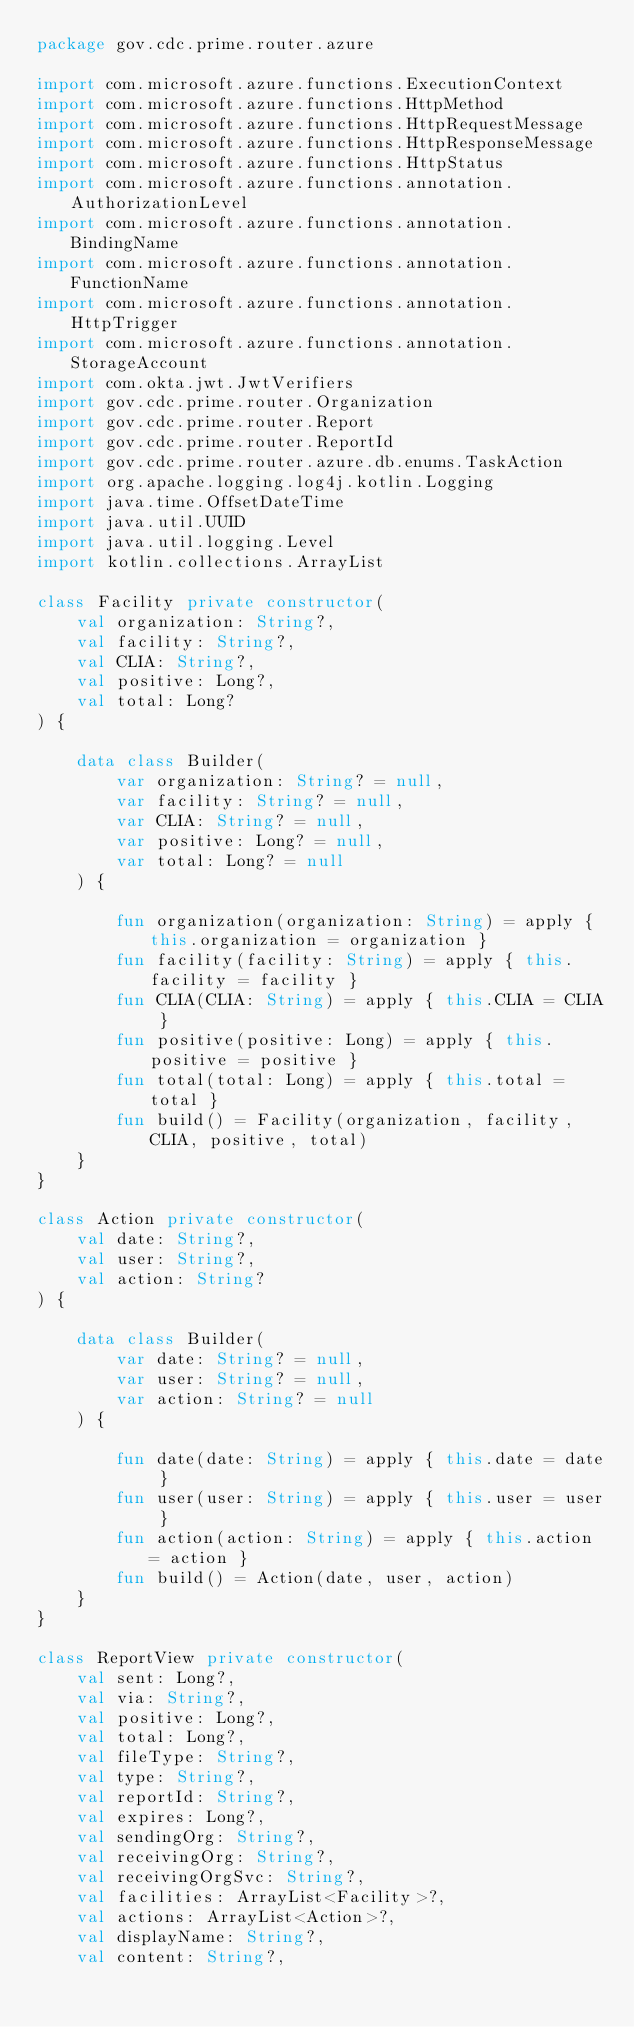Convert code to text. <code><loc_0><loc_0><loc_500><loc_500><_Kotlin_>package gov.cdc.prime.router.azure

import com.microsoft.azure.functions.ExecutionContext
import com.microsoft.azure.functions.HttpMethod
import com.microsoft.azure.functions.HttpRequestMessage
import com.microsoft.azure.functions.HttpResponseMessage
import com.microsoft.azure.functions.HttpStatus
import com.microsoft.azure.functions.annotation.AuthorizationLevel
import com.microsoft.azure.functions.annotation.BindingName
import com.microsoft.azure.functions.annotation.FunctionName
import com.microsoft.azure.functions.annotation.HttpTrigger
import com.microsoft.azure.functions.annotation.StorageAccount
import com.okta.jwt.JwtVerifiers
import gov.cdc.prime.router.Organization
import gov.cdc.prime.router.Report
import gov.cdc.prime.router.ReportId
import gov.cdc.prime.router.azure.db.enums.TaskAction
import org.apache.logging.log4j.kotlin.Logging
import java.time.OffsetDateTime
import java.util.UUID
import java.util.logging.Level
import kotlin.collections.ArrayList

class Facility private constructor(
    val organization: String?,
    val facility: String?,
    val CLIA: String?,
    val positive: Long?,
    val total: Long?
) {

    data class Builder(
        var organization: String? = null,
        var facility: String? = null,
        var CLIA: String? = null,
        var positive: Long? = null,
        var total: Long? = null
    ) {

        fun organization(organization: String) = apply { this.organization = organization }
        fun facility(facility: String) = apply { this.facility = facility }
        fun CLIA(CLIA: String) = apply { this.CLIA = CLIA }
        fun positive(positive: Long) = apply { this.positive = positive }
        fun total(total: Long) = apply { this.total = total }
        fun build() = Facility(organization, facility, CLIA, positive, total)
    }
}

class Action private constructor(
    val date: String?,
    val user: String?,
    val action: String?
) {

    data class Builder(
        var date: String? = null,
        var user: String? = null,
        var action: String? = null
    ) {

        fun date(date: String) = apply { this.date = date }
        fun user(user: String) = apply { this.user = user }
        fun action(action: String) = apply { this.action = action }
        fun build() = Action(date, user, action)
    }
}

class ReportView private constructor(
    val sent: Long?,
    val via: String?,
    val positive: Long?,
    val total: Long?,
    val fileType: String?,
    val type: String?,
    val reportId: String?,
    val expires: Long?,
    val sendingOrg: String?,
    val receivingOrg: String?,
    val receivingOrgSvc: String?,
    val facilities: ArrayList<Facility>?,
    val actions: ArrayList<Action>?,
    val displayName: String?,
    val content: String?,</code> 